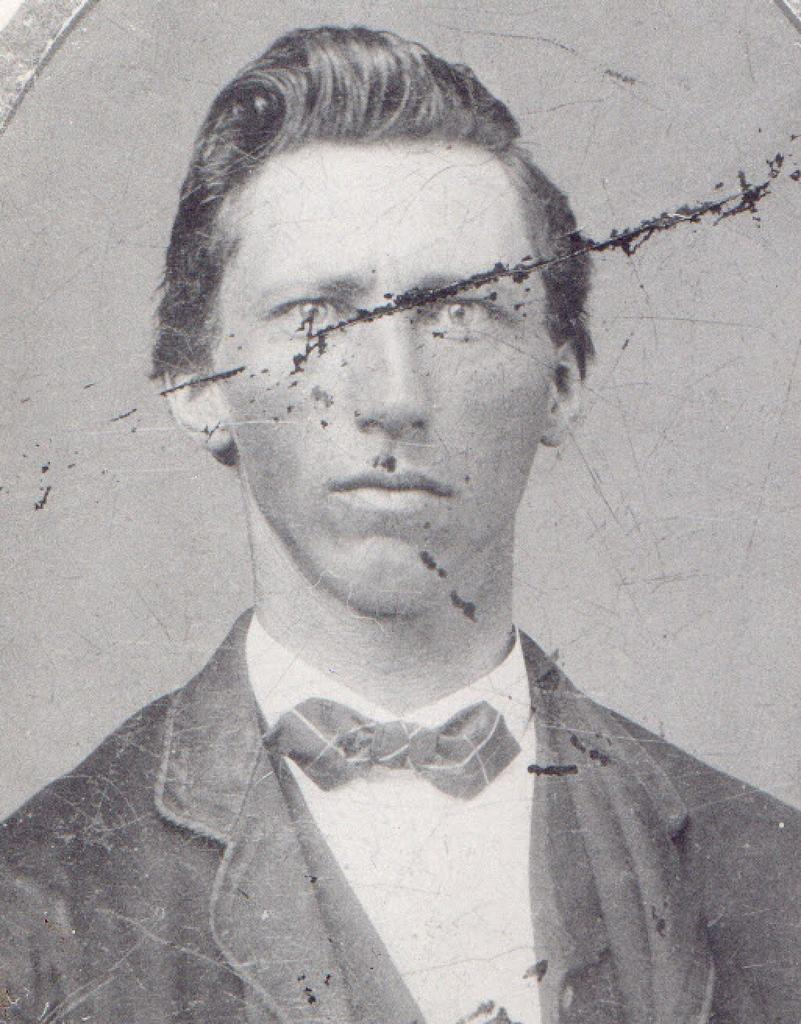What is the color scheme of the image? The image is black and white. Who is present in the image? There is a man in the image. What is the man wearing? The man is wearing a suit and a shirt. What other object can be seen in the image? There is a bowl in the image. What type of jewel is the man's daughter wearing in the image? There is no mention of a daughter or a jewel in the image; it only features a man and a bowl. 